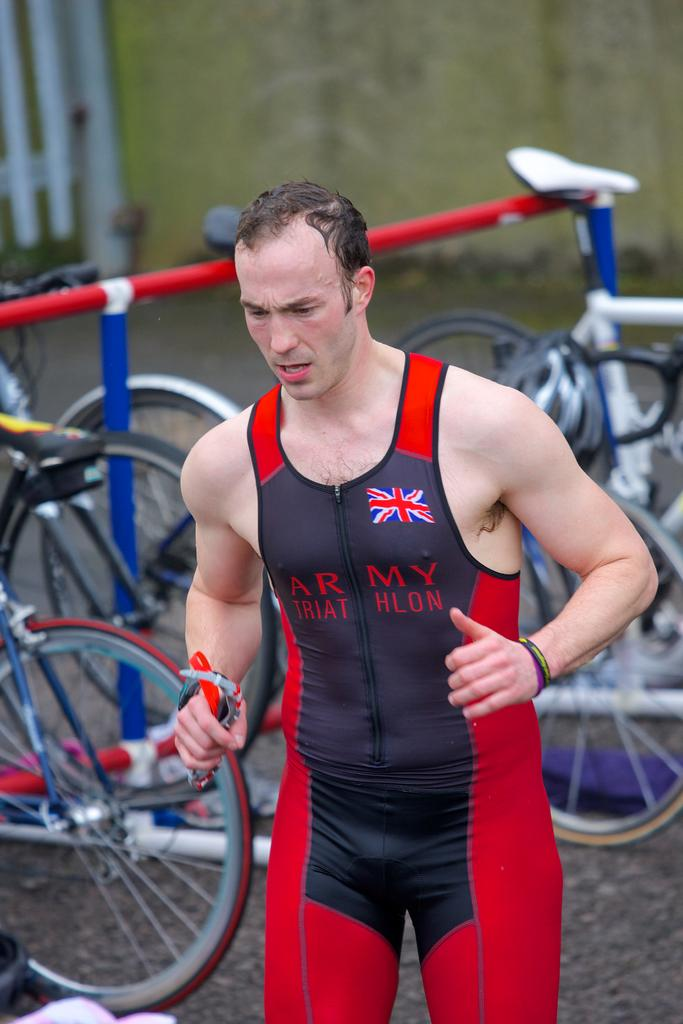<image>
Provide a brief description of the given image. a man that has Triathlon on his outfit 